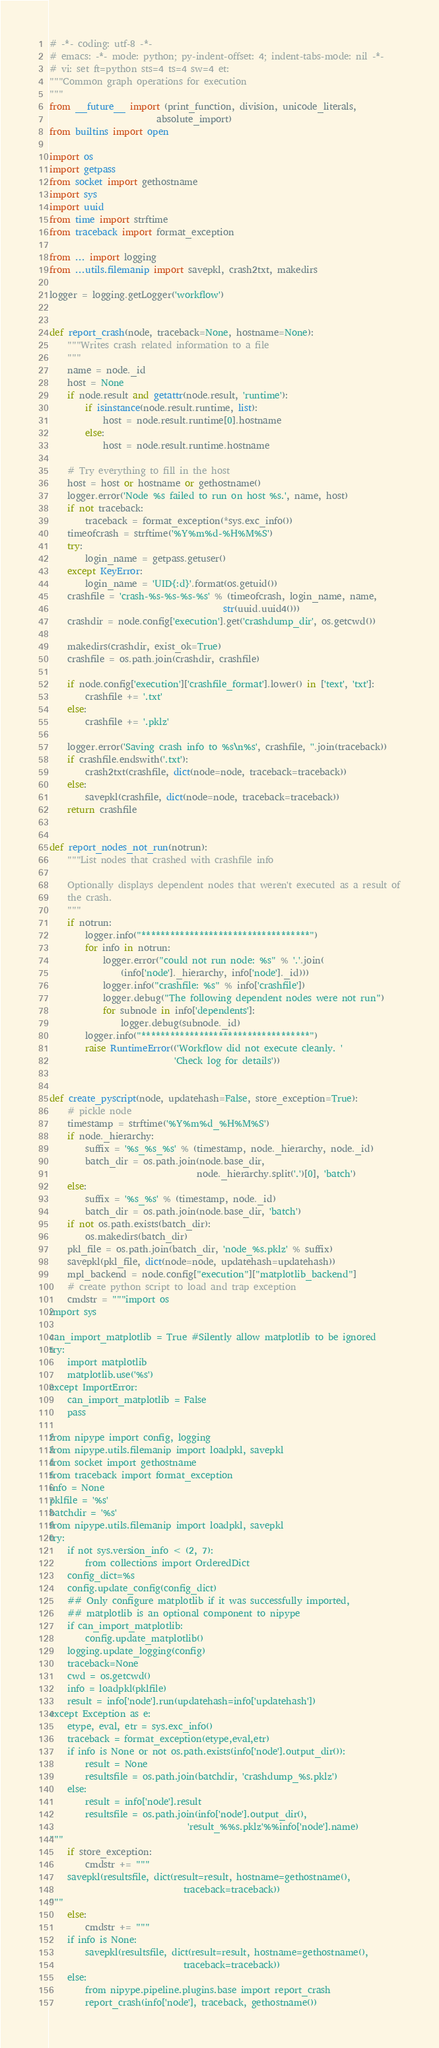<code> <loc_0><loc_0><loc_500><loc_500><_Python_># -*- coding: utf-8 -*-
# emacs: -*- mode: python; py-indent-offset: 4; indent-tabs-mode: nil -*-
# vi: set ft=python sts=4 ts=4 sw=4 et:
"""Common graph operations for execution
"""
from __future__ import (print_function, division, unicode_literals,
                        absolute_import)
from builtins import open

import os
import getpass
from socket import gethostname
import sys
import uuid
from time import strftime
from traceback import format_exception

from ... import logging
from ...utils.filemanip import savepkl, crash2txt, makedirs

logger = logging.getLogger('workflow')


def report_crash(node, traceback=None, hostname=None):
    """Writes crash related information to a file
    """
    name = node._id
    host = None
    if node.result and getattr(node.result, 'runtime'):
        if isinstance(node.result.runtime, list):
            host = node.result.runtime[0].hostname
        else:
            host = node.result.runtime.hostname

    # Try everything to fill in the host
    host = host or hostname or gethostname()
    logger.error('Node %s failed to run on host %s.', name, host)
    if not traceback:
        traceback = format_exception(*sys.exc_info())
    timeofcrash = strftime('%Y%m%d-%H%M%S')
    try:
        login_name = getpass.getuser()
    except KeyError:
        login_name = 'UID{:d}'.format(os.getuid())
    crashfile = 'crash-%s-%s-%s-%s' % (timeofcrash, login_name, name,
                                       str(uuid.uuid4()))
    crashdir = node.config['execution'].get('crashdump_dir', os.getcwd())

    makedirs(crashdir, exist_ok=True)
    crashfile = os.path.join(crashdir, crashfile)

    if node.config['execution']['crashfile_format'].lower() in ['text', 'txt']:
        crashfile += '.txt'
    else:
        crashfile += '.pklz'

    logger.error('Saving crash info to %s\n%s', crashfile, ''.join(traceback))
    if crashfile.endswith('.txt'):
        crash2txt(crashfile, dict(node=node, traceback=traceback))
    else:
        savepkl(crashfile, dict(node=node, traceback=traceback))
    return crashfile


def report_nodes_not_run(notrun):
    """List nodes that crashed with crashfile info

    Optionally displays dependent nodes that weren't executed as a result of
    the crash.
    """
    if notrun:
        logger.info("***********************************")
        for info in notrun:
            logger.error("could not run node: %s" % '.'.join(
                (info['node']._hierarchy, info['node']._id)))
            logger.info("crashfile: %s" % info['crashfile'])
            logger.debug("The following dependent nodes were not run")
            for subnode in info['dependents']:
                logger.debug(subnode._id)
        logger.info("***********************************")
        raise RuntimeError(('Workflow did not execute cleanly. '
                            'Check log for details'))


def create_pyscript(node, updatehash=False, store_exception=True):
    # pickle node
    timestamp = strftime('%Y%m%d_%H%M%S')
    if node._hierarchy:
        suffix = '%s_%s_%s' % (timestamp, node._hierarchy, node._id)
        batch_dir = os.path.join(node.base_dir,
                                 node._hierarchy.split('.')[0], 'batch')
    else:
        suffix = '%s_%s' % (timestamp, node._id)
        batch_dir = os.path.join(node.base_dir, 'batch')
    if not os.path.exists(batch_dir):
        os.makedirs(batch_dir)
    pkl_file = os.path.join(batch_dir, 'node_%s.pklz' % suffix)
    savepkl(pkl_file, dict(node=node, updatehash=updatehash))
    mpl_backend = node.config["execution"]["matplotlib_backend"]
    # create python script to load and trap exception
    cmdstr = """import os
import sys

can_import_matplotlib = True #Silently allow matplotlib to be ignored
try:
    import matplotlib
    matplotlib.use('%s')
except ImportError:
    can_import_matplotlib = False
    pass

from nipype import config, logging
from nipype.utils.filemanip import loadpkl, savepkl
from socket import gethostname
from traceback import format_exception
info = None
pklfile = '%s'
batchdir = '%s'
from nipype.utils.filemanip import loadpkl, savepkl
try:
    if not sys.version_info < (2, 7):
        from collections import OrderedDict
    config_dict=%s
    config.update_config(config_dict)
    ## Only configure matplotlib if it was successfully imported,
    ## matplotlib is an optional component to nipype
    if can_import_matplotlib:
        config.update_matplotlib()
    logging.update_logging(config)
    traceback=None
    cwd = os.getcwd()
    info = loadpkl(pklfile)
    result = info['node'].run(updatehash=info['updatehash'])
except Exception as e:
    etype, eval, etr = sys.exc_info()
    traceback = format_exception(etype,eval,etr)
    if info is None or not os.path.exists(info['node'].output_dir()):
        result = None
        resultsfile = os.path.join(batchdir, 'crashdump_%s.pklz')
    else:
        result = info['node'].result
        resultsfile = os.path.join(info['node'].output_dir(),
                               'result_%%s.pklz'%%info['node'].name)
"""
    if store_exception:
        cmdstr += """
    savepkl(resultsfile, dict(result=result, hostname=gethostname(),
                              traceback=traceback))
"""
    else:
        cmdstr += """
    if info is None:
        savepkl(resultsfile, dict(result=result, hostname=gethostname(),
                              traceback=traceback))
    else:
        from nipype.pipeline.plugins.base import report_crash
        report_crash(info['node'], traceback, gethostname())</code> 